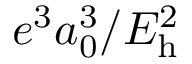<formula> <loc_0><loc_0><loc_500><loc_500>e ^ { 3 } a _ { 0 } ^ { 3 } / E _ { h } ^ { 2 }</formula> 